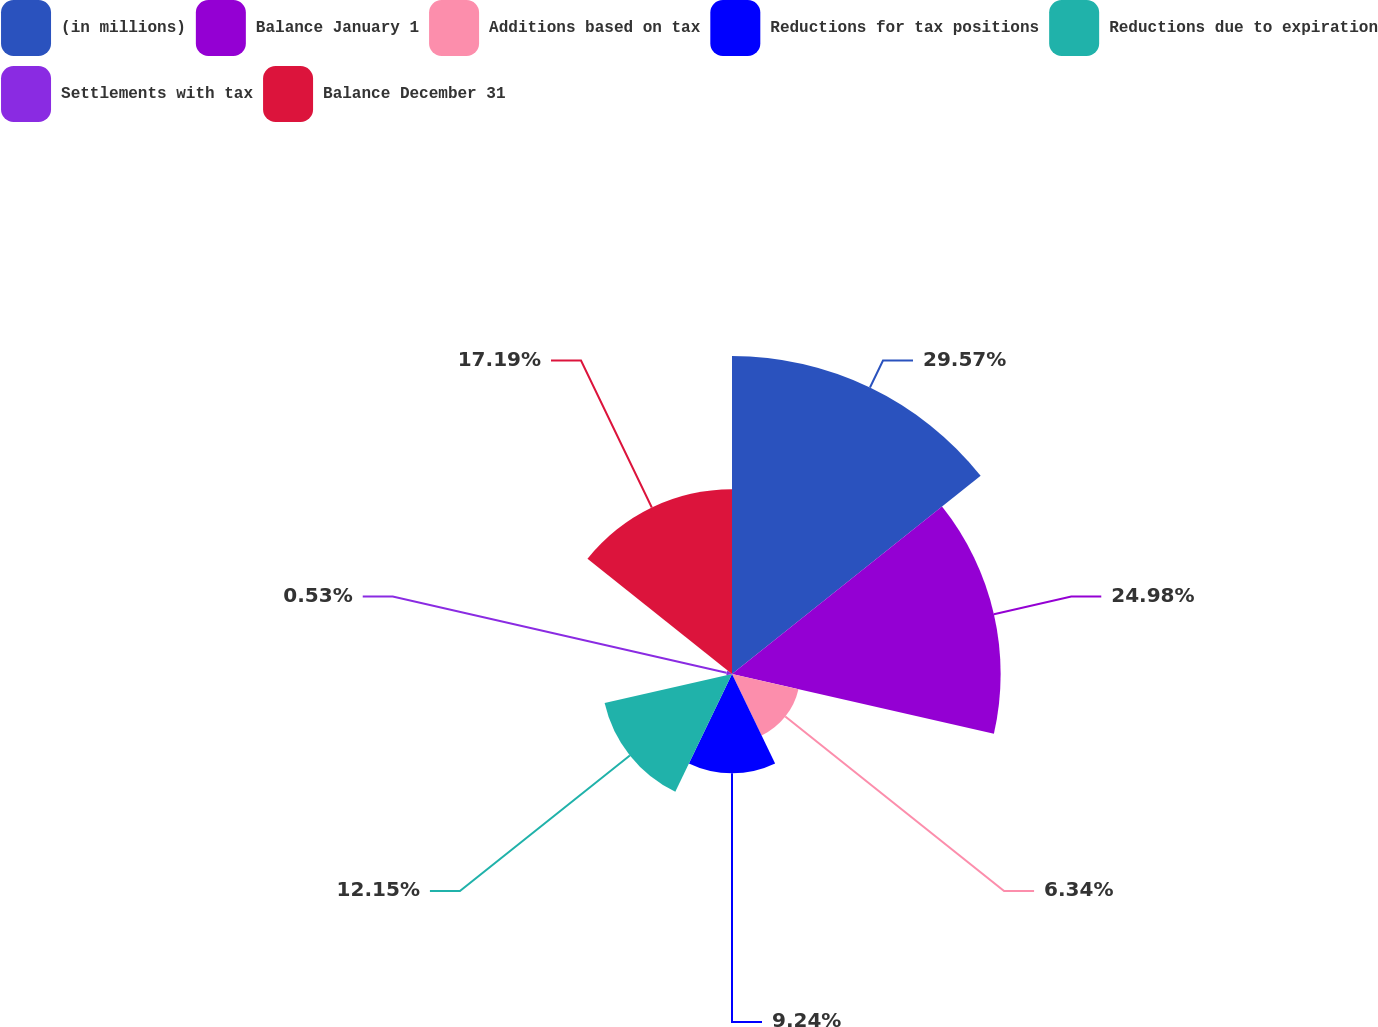Convert chart. <chart><loc_0><loc_0><loc_500><loc_500><pie_chart><fcel>(in millions)<fcel>Balance January 1<fcel>Additions based on tax<fcel>Reductions for tax positions<fcel>Reductions due to expiration<fcel>Settlements with tax<fcel>Balance December 31<nl><fcel>29.57%<fcel>24.98%<fcel>6.34%<fcel>9.24%<fcel>12.15%<fcel>0.53%<fcel>17.19%<nl></chart> 